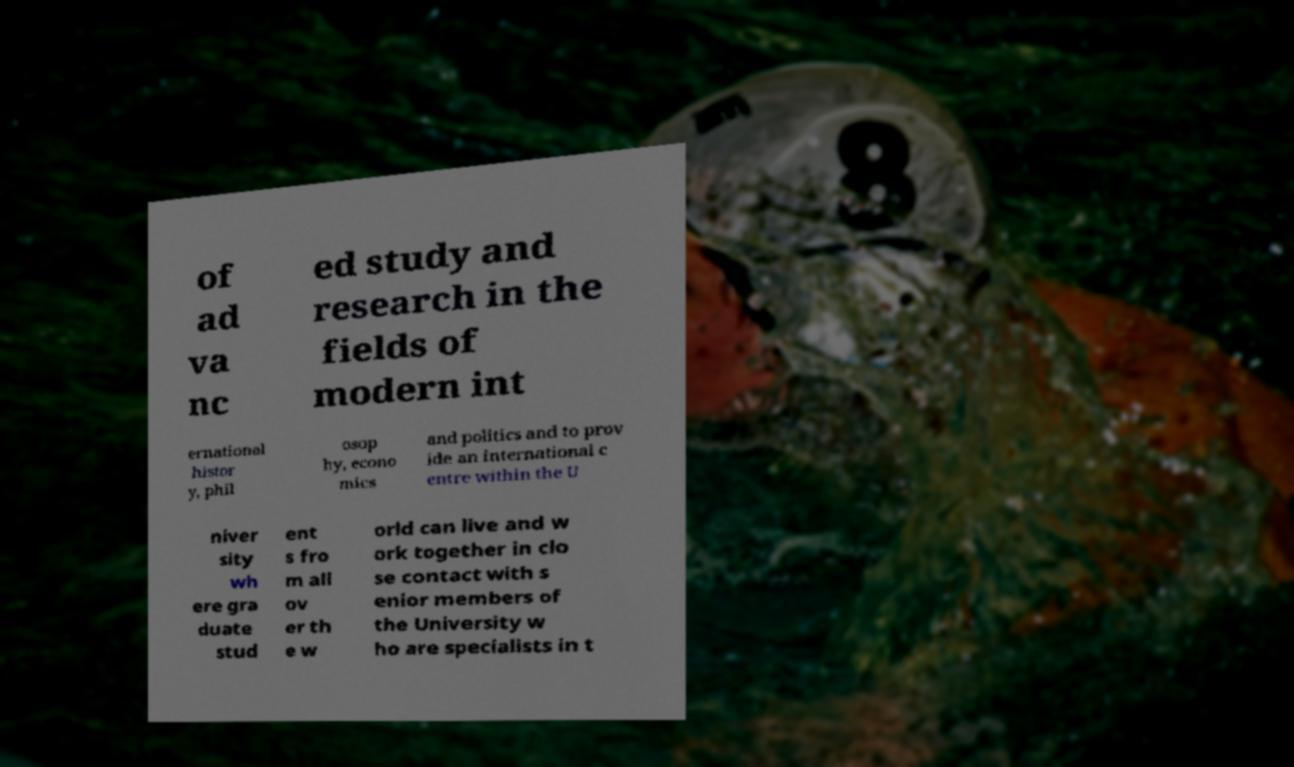Can you read and provide the text displayed in the image?This photo seems to have some interesting text. Can you extract and type it out for me? of ad va nc ed study and research in the fields of modern int ernational histor y, phil osop hy, econo mics and politics and to prov ide an international c entre within the U niver sity wh ere gra duate stud ent s fro m all ov er th e w orld can live and w ork together in clo se contact with s enior members of the University w ho are specialists in t 